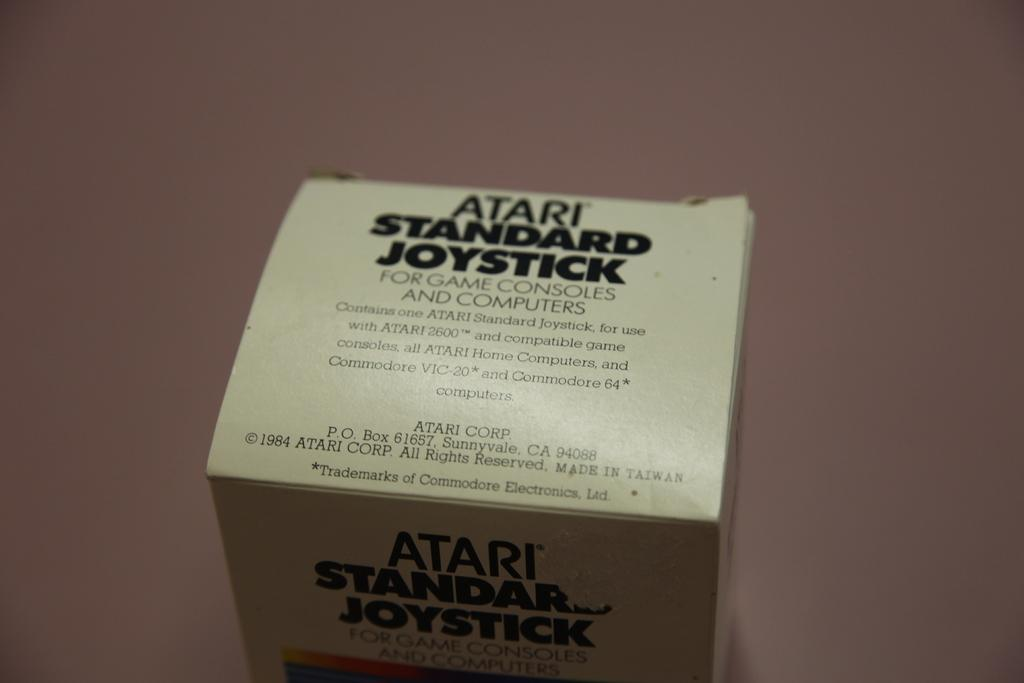Provide a one-sentence caption for the provided image. A box saying it contains an Atari standard joystick. 